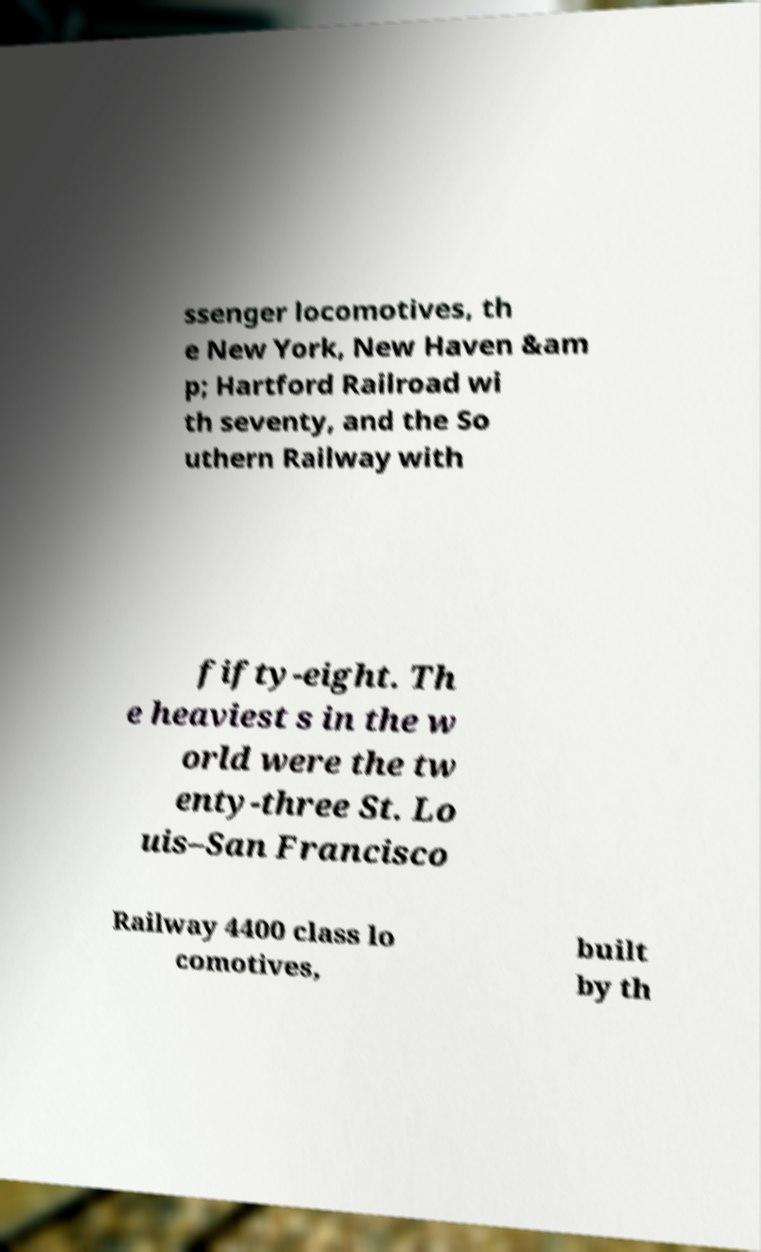Please identify and transcribe the text found in this image. ssenger locomotives, th e New York, New Haven &am p; Hartford Railroad wi th seventy, and the So uthern Railway with fifty-eight. Th e heaviest s in the w orld were the tw enty-three St. Lo uis–San Francisco Railway 4400 class lo comotives, built by th 